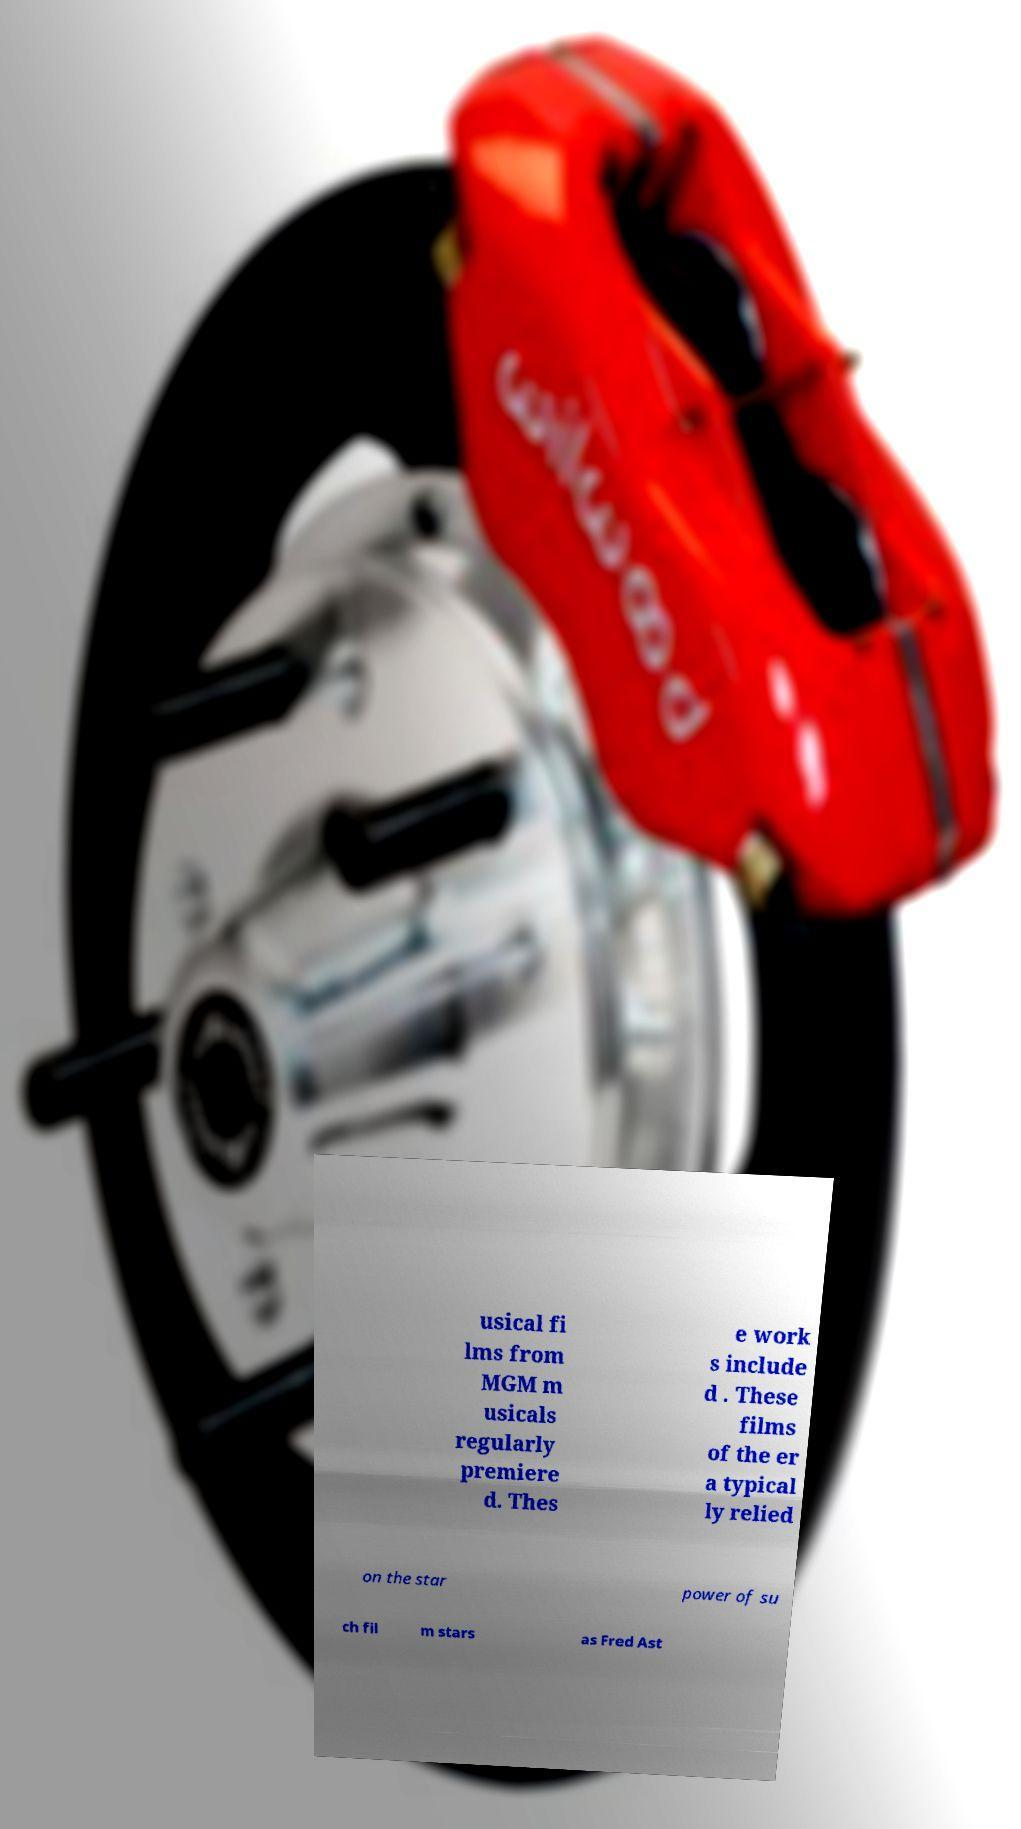Please identify and transcribe the text found in this image. usical fi lms from MGM m usicals regularly premiere d. Thes e work s include d . These films of the er a typical ly relied on the star power of su ch fil m stars as Fred Ast 